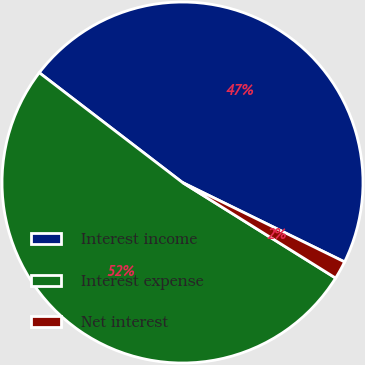Convert chart. <chart><loc_0><loc_0><loc_500><loc_500><pie_chart><fcel>Interest income<fcel>Interest expense<fcel>Net interest<nl><fcel>46.84%<fcel>51.53%<fcel>1.63%<nl></chart> 